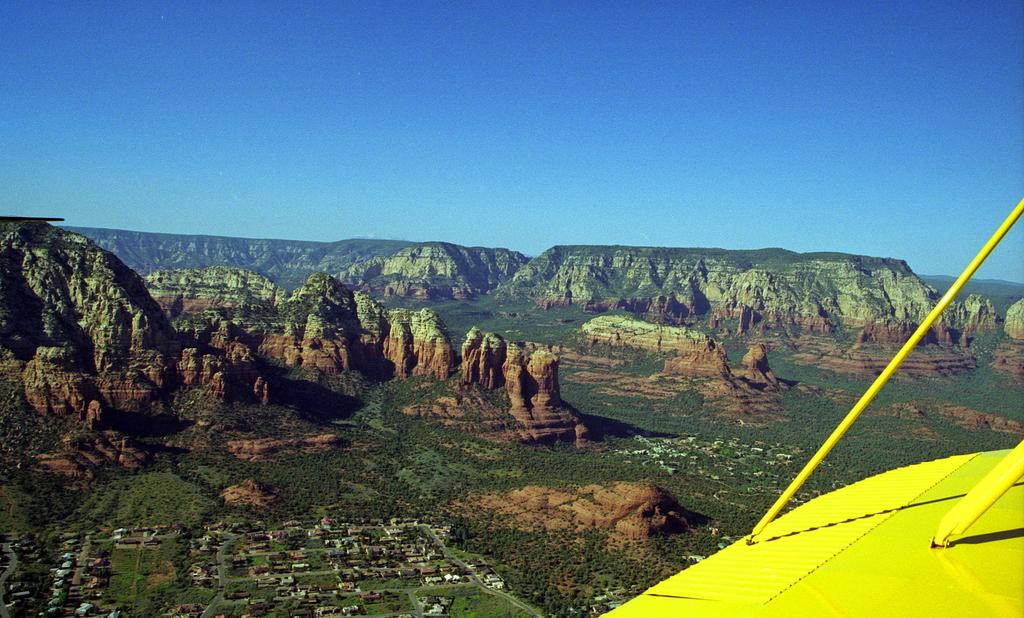What type of vegetation can be seen in the image? There is grass in the image, and it is green. How many houses are visible in the image, and what colors are they? There are houses in the image, and they are in multiple colors. What can be seen in the background of the image? There are rocks visible in the background of the image. What color is the sky in the image? The sky is blue in the image. What type of texture does the sponge have in the image? There is no sponge present in the image. How many houses are depicted on the side of the sponge in the image? There is no sponge or houses on a sponge present in the image. 